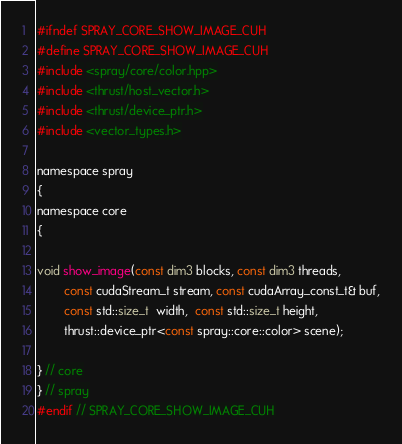Convert code to text. <code><loc_0><loc_0><loc_500><loc_500><_Cuda_>#ifndef SPRAY_CORE_SHOW_IMAGE_CUH
#define SPRAY_CORE_SHOW_IMAGE_CUH
#include <spray/core/color.hpp>
#include <thrust/host_vector.h>
#include <thrust/device_ptr.h>
#include <vector_types.h>

namespace spray
{
namespace core
{

void show_image(const dim3 blocks, const dim3 threads,
        const cudaStream_t stream, const cudaArray_const_t& buf,
        const std::size_t  width,  const std::size_t height,
        thrust::device_ptr<const spray::core::color> scene);

} // core
} // spray
#endif // SPRAY_CORE_SHOW_IMAGE_CUH
</code> 